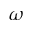Convert formula to latex. <formula><loc_0><loc_0><loc_500><loc_500>\omega</formula> 